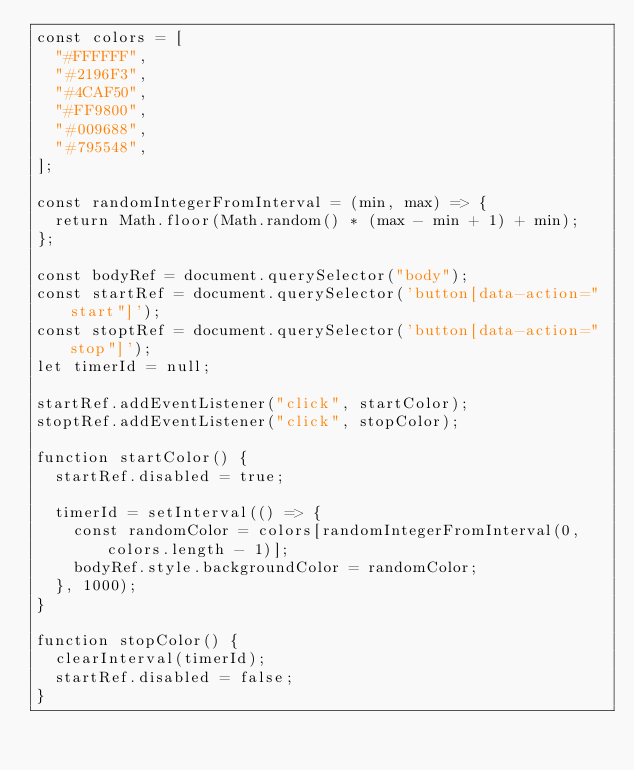<code> <loc_0><loc_0><loc_500><loc_500><_JavaScript_>const colors = [
  "#FFFFFF",
  "#2196F3",
  "#4CAF50",
  "#FF9800",
  "#009688",
  "#795548",
];

const randomIntegerFromInterval = (min, max) => {
  return Math.floor(Math.random() * (max - min + 1) + min);
};

const bodyRef = document.querySelector("body");
const startRef = document.querySelector('button[data-action="start"]');
const stoptRef = document.querySelector('button[data-action="stop"]');
let timerId = null;

startRef.addEventListener("click", startColor);
stoptRef.addEventListener("click", stopColor);

function startColor() {
  startRef.disabled = true;

  timerId = setInterval(() => {
    const randomColor = colors[randomIntegerFromInterval(0, colors.length - 1)];
    bodyRef.style.backgroundColor = randomColor;    
  }, 1000);
}

function stopColor() {
  clearInterval(timerId);
  startRef.disabled = false;
}
</code> 